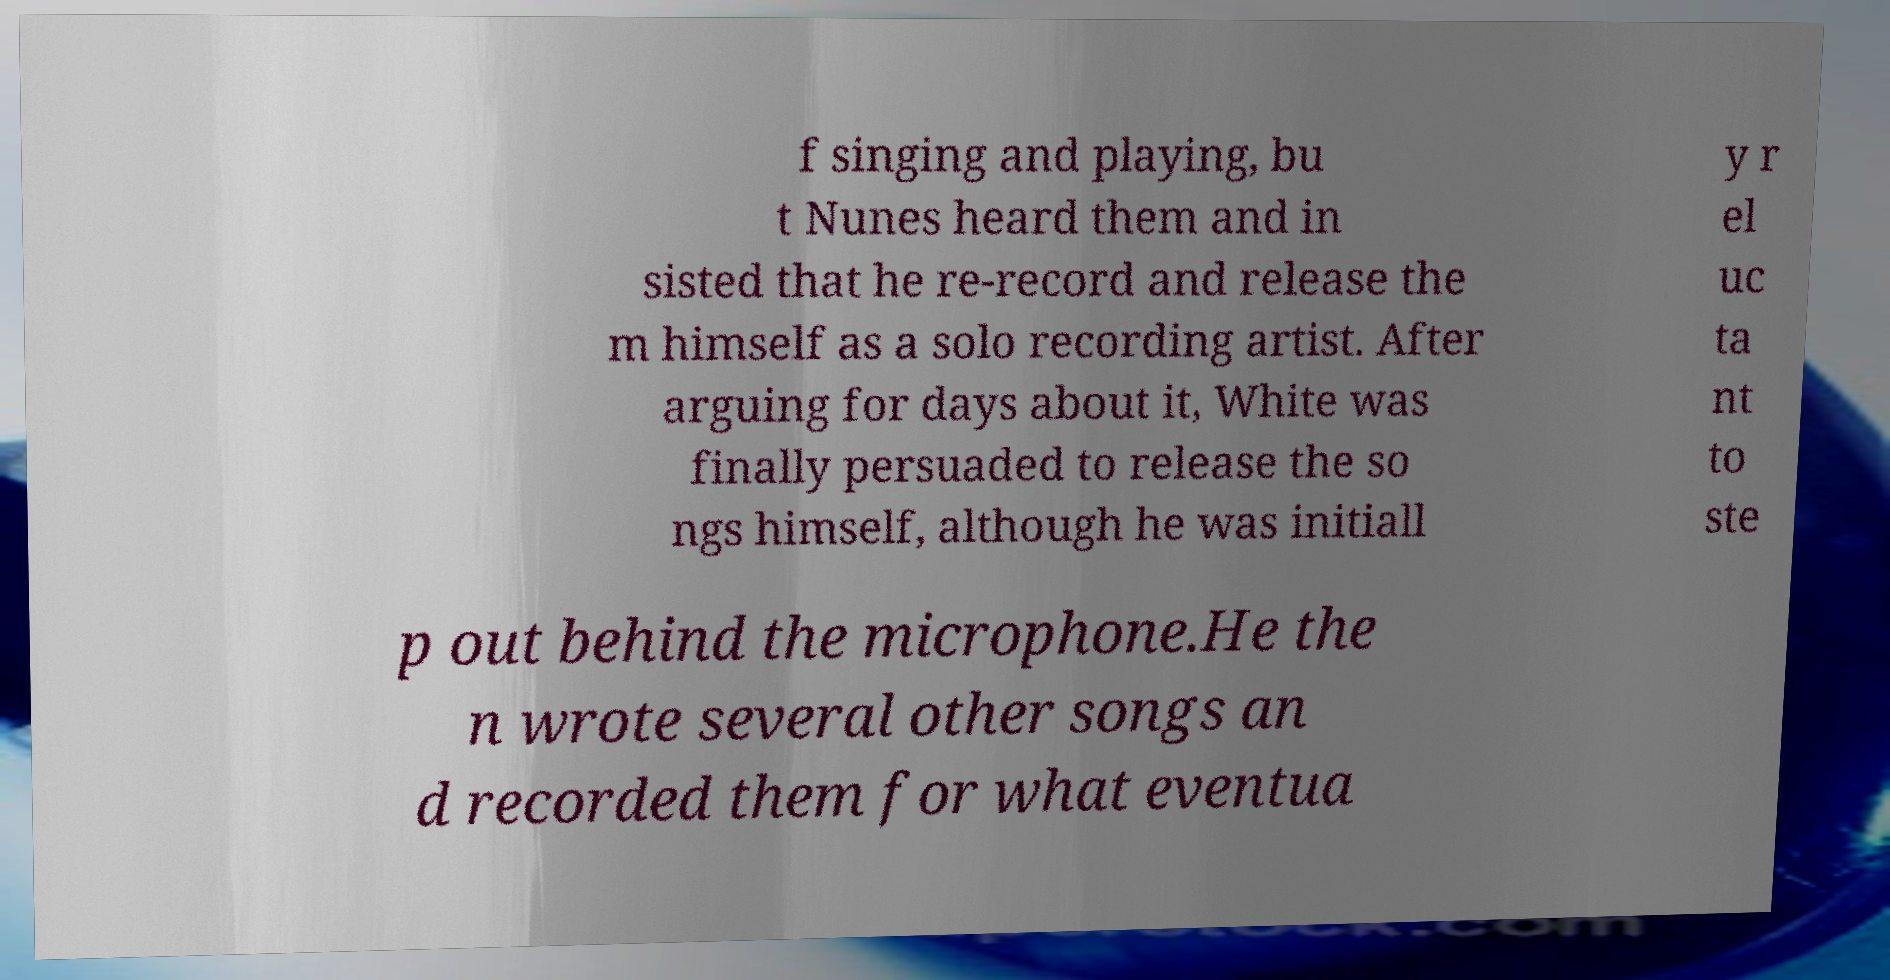There's text embedded in this image that I need extracted. Can you transcribe it verbatim? f singing and playing, bu t Nunes heard them and in sisted that he re-record and release the m himself as a solo recording artist. After arguing for days about it, White was finally persuaded to release the so ngs himself, although he was initiall y r el uc ta nt to ste p out behind the microphone.He the n wrote several other songs an d recorded them for what eventua 